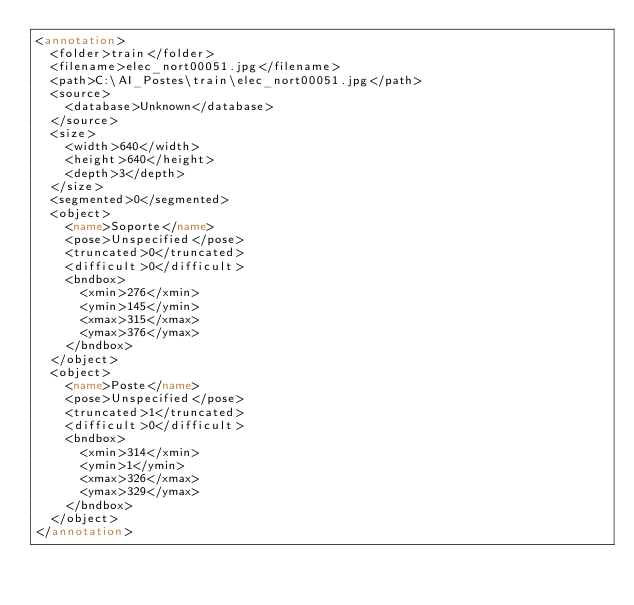Convert code to text. <code><loc_0><loc_0><loc_500><loc_500><_XML_><annotation>
	<folder>train</folder>
	<filename>elec_nort00051.jpg</filename>
	<path>C:\AI_Postes\train\elec_nort00051.jpg</path>
	<source>
		<database>Unknown</database>
	</source>
	<size>
		<width>640</width>
		<height>640</height>
		<depth>3</depth>
	</size>
	<segmented>0</segmented>
	<object>
		<name>Soporte</name>
		<pose>Unspecified</pose>
		<truncated>0</truncated>
		<difficult>0</difficult>
		<bndbox>
			<xmin>276</xmin>
			<ymin>145</ymin>
			<xmax>315</xmax>
			<ymax>376</ymax>
		</bndbox>
	</object>
	<object>
		<name>Poste</name>
		<pose>Unspecified</pose>
		<truncated>1</truncated>
		<difficult>0</difficult>
		<bndbox>
			<xmin>314</xmin>
			<ymin>1</ymin>
			<xmax>326</xmax>
			<ymax>329</ymax>
		</bndbox>
	</object>
</annotation>
</code> 